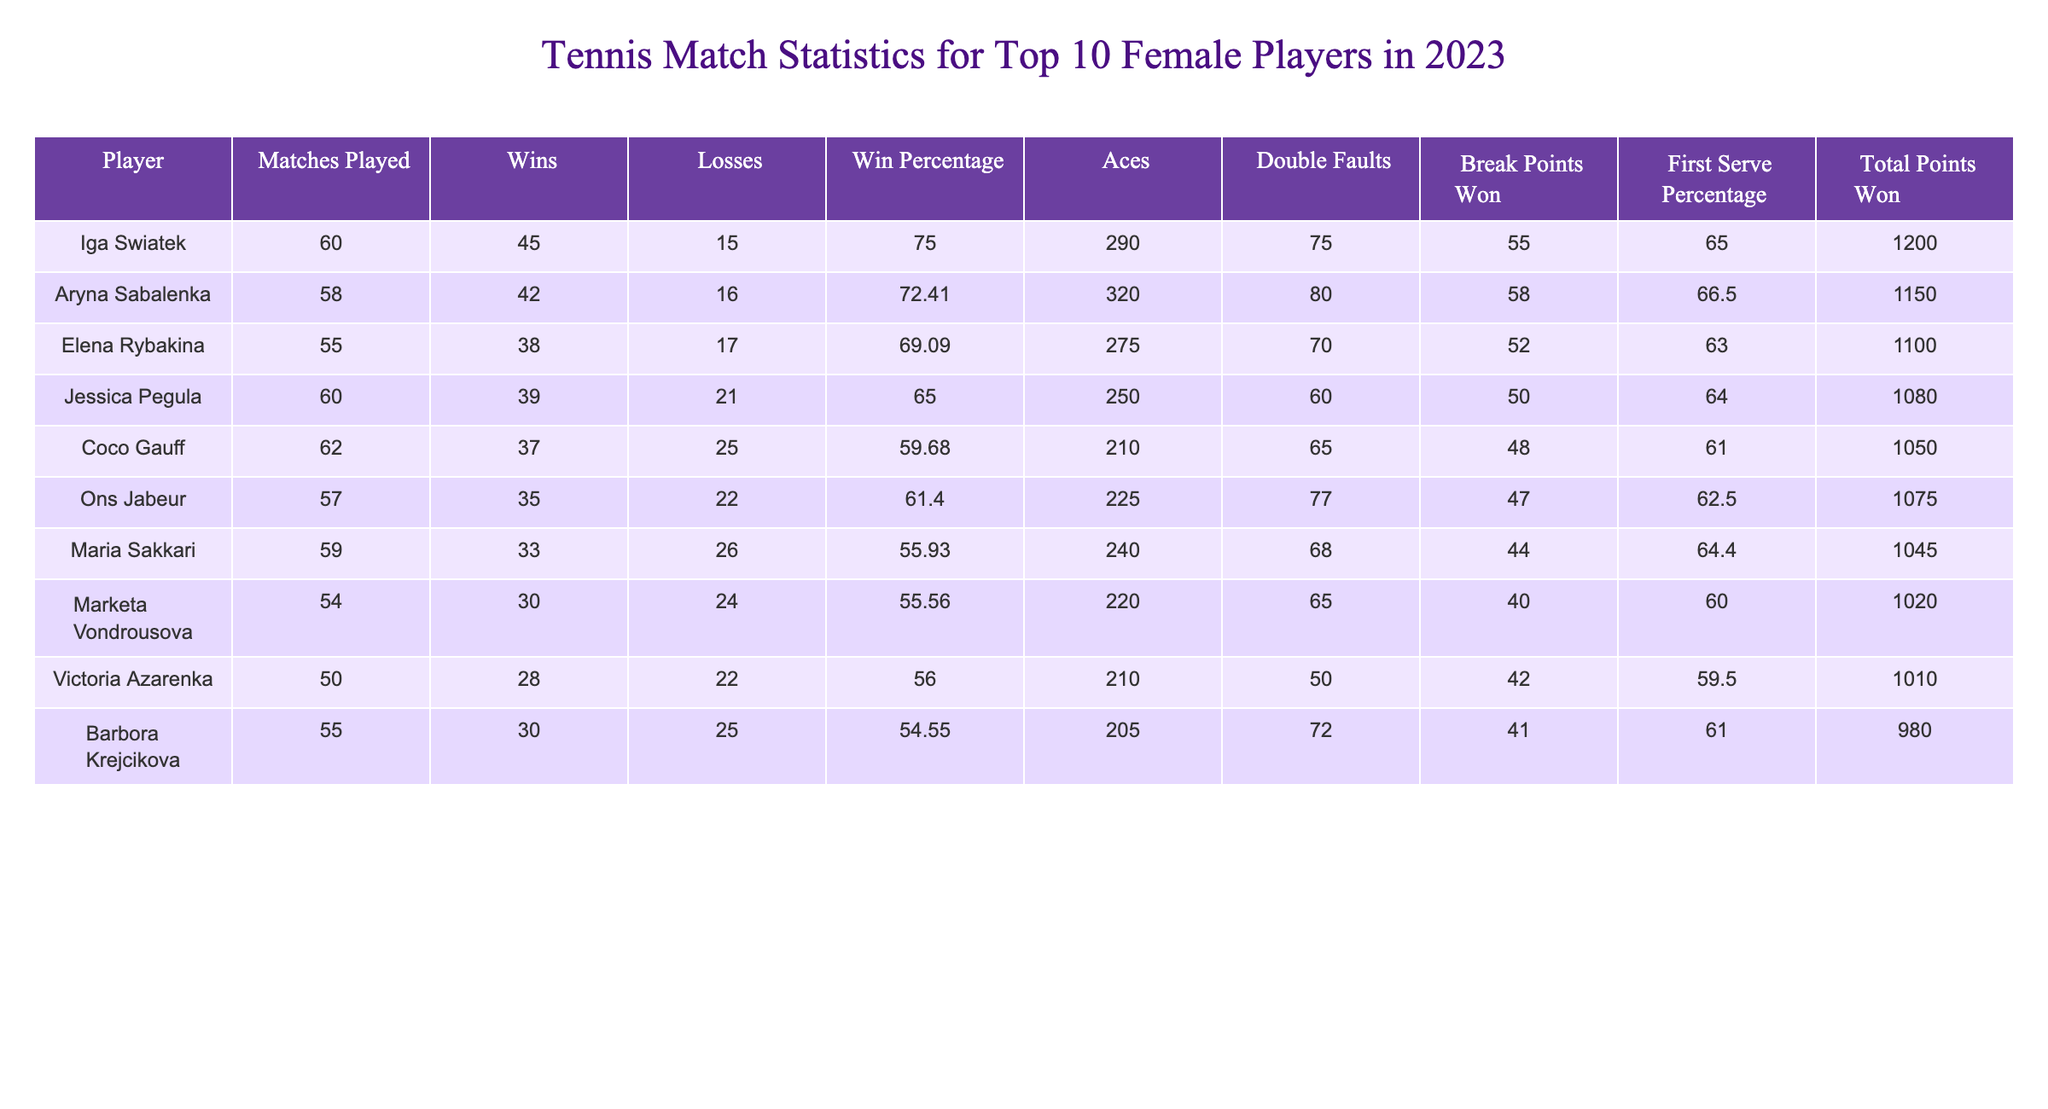What is the win percentage of Iga Swiatek? The win percentage is listed in the table under "Win Percentage" for Iga Swiatek as 75.00.
Answer: 75.00 How many total points did Aryna Sabalenka win? The total points won by Aryna Sabalenka can be found in the "Total Points Won" column, which is 1150.
Answer: 1150 Who has the highest number of aces and how many did they serve? To find the highest number of aces, I compare the "Aces" column. Aryna Sabalenka has the highest with 320 aces.
Answer: Aryna Sabalenka, 320 What is the average win percentage of the top 10 players? To find the average win percentage, I sum the win percentages of all players (75.00 + 72.41 + 69.09 + 65.00 + 59.68 + 61.40 + 55.93 + 55.56 + 56.00 + 54.55 =  675.62) and divide by 10, resulting in 67.56.
Answer: 67.56 Which player had the most double faults and how many did they commit? I check the "Double Faults" column for the maximum value. Iga Swiatek has the most double faults with 75.
Answer: Iga Swiatek, 75 Is it true that Coco Gauff has more matches played than Jessica Pegula? I will compare the "Matches Played" column for both players. Coco Gauff played 62 matches while Jessica Pegula played 60 matches, so it is true.
Answer: Yes Which player had the lowest percentage of first serve? I look for the lowest value in the "First Serve Percentage" column. Coco Gauff has the lowest at 61.00%.
Answer: Coco Gauff What is the difference in total points won between Elena Rybakina and Maria Sakkari? The value for Elena Rybakina is 1100 and for Maria Sakkari is 1045. The difference is 1100 - 1045 = 55.
Answer: 55 How many players had a win percentage above 70%? I tally players with a "Win Percentage" greater than 70. Iga Swiatek and Aryna Sabalenka both exceed 70%, so there are 2 players.
Answer: 2 If we combine the wins for the top two players, what is the total? I add the "Wins" of Iga Swiatek (45) and Aryna Sabalenka (42) together: 45 + 42 = 87.
Answer: 87 